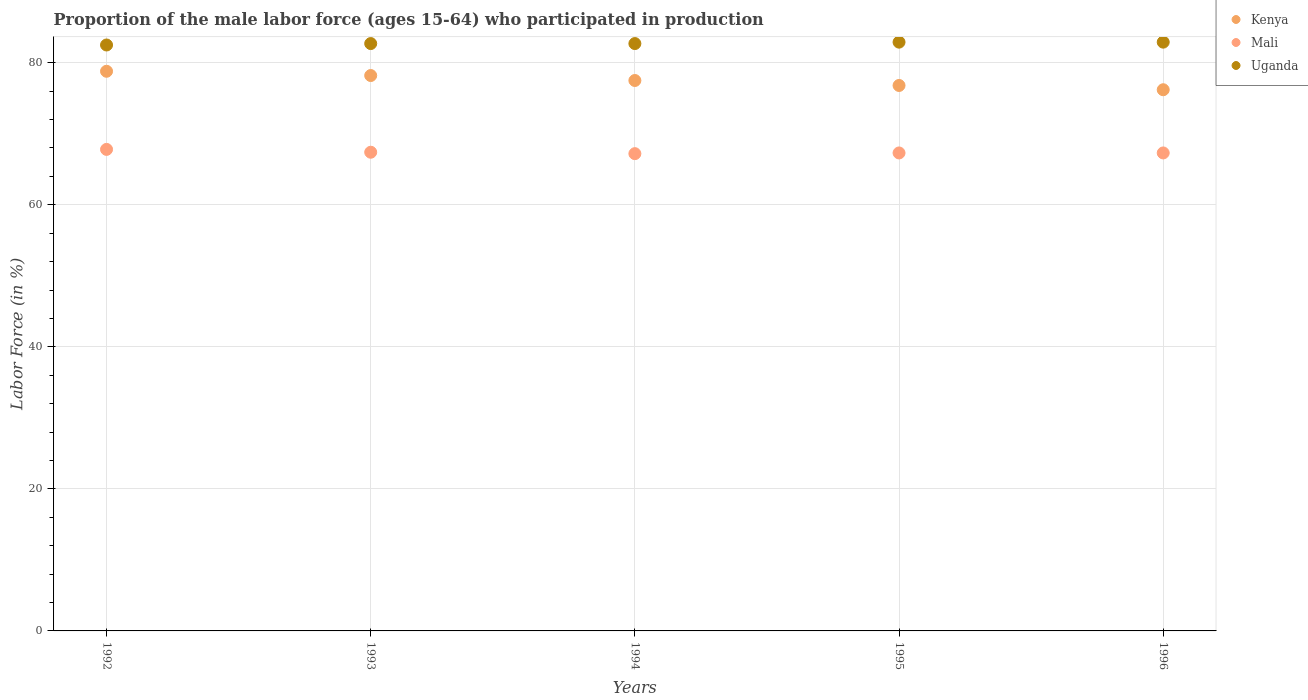How many different coloured dotlines are there?
Keep it short and to the point. 3. What is the proportion of the male labor force who participated in production in Uganda in 1993?
Your answer should be compact. 82.7. Across all years, what is the maximum proportion of the male labor force who participated in production in Uganda?
Make the answer very short. 82.9. Across all years, what is the minimum proportion of the male labor force who participated in production in Kenya?
Ensure brevity in your answer.  76.2. In which year was the proportion of the male labor force who participated in production in Kenya maximum?
Ensure brevity in your answer.  1992. In which year was the proportion of the male labor force who participated in production in Mali minimum?
Your answer should be very brief. 1994. What is the total proportion of the male labor force who participated in production in Mali in the graph?
Provide a succinct answer. 337. What is the difference between the proportion of the male labor force who participated in production in Uganda in 1992 and that in 1996?
Keep it short and to the point. -0.4. What is the average proportion of the male labor force who participated in production in Kenya per year?
Your answer should be very brief. 77.5. In the year 1994, what is the difference between the proportion of the male labor force who participated in production in Kenya and proportion of the male labor force who participated in production in Mali?
Your answer should be compact. 10.3. In how many years, is the proportion of the male labor force who participated in production in Mali greater than 76 %?
Keep it short and to the point. 0. What is the ratio of the proportion of the male labor force who participated in production in Kenya in 1992 to that in 1994?
Offer a very short reply. 1.02. Is the proportion of the male labor force who participated in production in Mali in 1992 less than that in 1996?
Offer a terse response. No. Is the difference between the proportion of the male labor force who participated in production in Kenya in 1992 and 1994 greater than the difference between the proportion of the male labor force who participated in production in Mali in 1992 and 1994?
Make the answer very short. Yes. What is the difference between the highest and the second highest proportion of the male labor force who participated in production in Kenya?
Keep it short and to the point. 0.6. What is the difference between the highest and the lowest proportion of the male labor force who participated in production in Kenya?
Give a very brief answer. 2.6. Is the sum of the proportion of the male labor force who participated in production in Mali in 1994 and 1995 greater than the maximum proportion of the male labor force who participated in production in Uganda across all years?
Your answer should be very brief. Yes. Does the proportion of the male labor force who participated in production in Mali monotonically increase over the years?
Provide a short and direct response. No. Are the values on the major ticks of Y-axis written in scientific E-notation?
Offer a very short reply. No. What is the title of the graph?
Make the answer very short. Proportion of the male labor force (ages 15-64) who participated in production. Does "Faeroe Islands" appear as one of the legend labels in the graph?
Provide a succinct answer. No. What is the label or title of the X-axis?
Keep it short and to the point. Years. What is the label or title of the Y-axis?
Offer a terse response. Labor Force (in %). What is the Labor Force (in %) of Kenya in 1992?
Give a very brief answer. 78.8. What is the Labor Force (in %) of Mali in 1992?
Keep it short and to the point. 67.8. What is the Labor Force (in %) in Uganda in 1992?
Offer a very short reply. 82.5. What is the Labor Force (in %) of Kenya in 1993?
Provide a short and direct response. 78.2. What is the Labor Force (in %) in Mali in 1993?
Ensure brevity in your answer.  67.4. What is the Labor Force (in %) of Uganda in 1993?
Offer a very short reply. 82.7. What is the Labor Force (in %) in Kenya in 1994?
Your answer should be very brief. 77.5. What is the Labor Force (in %) in Mali in 1994?
Make the answer very short. 67.2. What is the Labor Force (in %) in Uganda in 1994?
Your response must be concise. 82.7. What is the Labor Force (in %) in Kenya in 1995?
Your response must be concise. 76.8. What is the Labor Force (in %) of Mali in 1995?
Keep it short and to the point. 67.3. What is the Labor Force (in %) of Uganda in 1995?
Offer a terse response. 82.9. What is the Labor Force (in %) in Kenya in 1996?
Provide a succinct answer. 76.2. What is the Labor Force (in %) in Mali in 1996?
Provide a succinct answer. 67.3. What is the Labor Force (in %) of Uganda in 1996?
Provide a succinct answer. 82.9. Across all years, what is the maximum Labor Force (in %) in Kenya?
Your answer should be compact. 78.8. Across all years, what is the maximum Labor Force (in %) of Mali?
Your response must be concise. 67.8. Across all years, what is the maximum Labor Force (in %) of Uganda?
Your response must be concise. 82.9. Across all years, what is the minimum Labor Force (in %) in Kenya?
Give a very brief answer. 76.2. Across all years, what is the minimum Labor Force (in %) in Mali?
Offer a terse response. 67.2. Across all years, what is the minimum Labor Force (in %) of Uganda?
Provide a succinct answer. 82.5. What is the total Labor Force (in %) of Kenya in the graph?
Ensure brevity in your answer.  387.5. What is the total Labor Force (in %) of Mali in the graph?
Your answer should be compact. 337. What is the total Labor Force (in %) of Uganda in the graph?
Keep it short and to the point. 413.7. What is the difference between the Labor Force (in %) in Uganda in 1992 and that in 1993?
Give a very brief answer. -0.2. What is the difference between the Labor Force (in %) in Kenya in 1992 and that in 1994?
Give a very brief answer. 1.3. What is the difference between the Labor Force (in %) in Mali in 1992 and that in 1994?
Provide a succinct answer. 0.6. What is the difference between the Labor Force (in %) of Kenya in 1992 and that in 1995?
Your response must be concise. 2. What is the difference between the Labor Force (in %) in Uganda in 1992 and that in 1995?
Make the answer very short. -0.4. What is the difference between the Labor Force (in %) of Kenya in 1992 and that in 1996?
Keep it short and to the point. 2.6. What is the difference between the Labor Force (in %) in Uganda in 1992 and that in 1996?
Offer a terse response. -0.4. What is the difference between the Labor Force (in %) of Mali in 1993 and that in 1994?
Offer a very short reply. 0.2. What is the difference between the Labor Force (in %) in Uganda in 1993 and that in 1994?
Keep it short and to the point. 0. What is the difference between the Labor Force (in %) in Mali in 1993 and that in 1995?
Offer a very short reply. 0.1. What is the difference between the Labor Force (in %) of Mali in 1993 and that in 1996?
Give a very brief answer. 0.1. What is the difference between the Labor Force (in %) of Uganda in 1993 and that in 1996?
Provide a succinct answer. -0.2. What is the difference between the Labor Force (in %) of Kenya in 1994 and that in 1995?
Ensure brevity in your answer.  0.7. What is the difference between the Labor Force (in %) of Mali in 1994 and that in 1995?
Give a very brief answer. -0.1. What is the difference between the Labor Force (in %) of Kenya in 1994 and that in 1996?
Give a very brief answer. 1.3. What is the difference between the Labor Force (in %) in Mali in 1994 and that in 1996?
Give a very brief answer. -0.1. What is the difference between the Labor Force (in %) of Uganda in 1994 and that in 1996?
Provide a short and direct response. -0.2. What is the difference between the Labor Force (in %) in Kenya in 1995 and that in 1996?
Keep it short and to the point. 0.6. What is the difference between the Labor Force (in %) of Mali in 1995 and that in 1996?
Keep it short and to the point. 0. What is the difference between the Labor Force (in %) of Kenya in 1992 and the Labor Force (in %) of Mali in 1993?
Ensure brevity in your answer.  11.4. What is the difference between the Labor Force (in %) of Kenya in 1992 and the Labor Force (in %) of Uganda in 1993?
Your answer should be very brief. -3.9. What is the difference between the Labor Force (in %) in Mali in 1992 and the Labor Force (in %) in Uganda in 1993?
Provide a succinct answer. -14.9. What is the difference between the Labor Force (in %) of Kenya in 1992 and the Labor Force (in %) of Uganda in 1994?
Provide a short and direct response. -3.9. What is the difference between the Labor Force (in %) in Mali in 1992 and the Labor Force (in %) in Uganda in 1994?
Keep it short and to the point. -14.9. What is the difference between the Labor Force (in %) in Kenya in 1992 and the Labor Force (in %) in Mali in 1995?
Offer a very short reply. 11.5. What is the difference between the Labor Force (in %) of Kenya in 1992 and the Labor Force (in %) of Uganda in 1995?
Offer a very short reply. -4.1. What is the difference between the Labor Force (in %) in Mali in 1992 and the Labor Force (in %) in Uganda in 1995?
Keep it short and to the point. -15.1. What is the difference between the Labor Force (in %) of Mali in 1992 and the Labor Force (in %) of Uganda in 1996?
Offer a terse response. -15.1. What is the difference between the Labor Force (in %) of Kenya in 1993 and the Labor Force (in %) of Mali in 1994?
Ensure brevity in your answer.  11. What is the difference between the Labor Force (in %) in Mali in 1993 and the Labor Force (in %) in Uganda in 1994?
Your response must be concise. -15.3. What is the difference between the Labor Force (in %) in Kenya in 1993 and the Labor Force (in %) in Mali in 1995?
Give a very brief answer. 10.9. What is the difference between the Labor Force (in %) in Kenya in 1993 and the Labor Force (in %) in Uganda in 1995?
Offer a very short reply. -4.7. What is the difference between the Labor Force (in %) in Mali in 1993 and the Labor Force (in %) in Uganda in 1995?
Provide a succinct answer. -15.5. What is the difference between the Labor Force (in %) of Kenya in 1993 and the Labor Force (in %) of Uganda in 1996?
Provide a succinct answer. -4.7. What is the difference between the Labor Force (in %) in Mali in 1993 and the Labor Force (in %) in Uganda in 1996?
Provide a short and direct response. -15.5. What is the difference between the Labor Force (in %) of Kenya in 1994 and the Labor Force (in %) of Uganda in 1995?
Your response must be concise. -5.4. What is the difference between the Labor Force (in %) of Mali in 1994 and the Labor Force (in %) of Uganda in 1995?
Offer a terse response. -15.7. What is the difference between the Labor Force (in %) in Mali in 1994 and the Labor Force (in %) in Uganda in 1996?
Your response must be concise. -15.7. What is the difference between the Labor Force (in %) in Kenya in 1995 and the Labor Force (in %) in Mali in 1996?
Offer a very short reply. 9.5. What is the difference between the Labor Force (in %) of Mali in 1995 and the Labor Force (in %) of Uganda in 1996?
Give a very brief answer. -15.6. What is the average Labor Force (in %) in Kenya per year?
Offer a very short reply. 77.5. What is the average Labor Force (in %) in Mali per year?
Offer a terse response. 67.4. What is the average Labor Force (in %) in Uganda per year?
Offer a terse response. 82.74. In the year 1992, what is the difference between the Labor Force (in %) of Kenya and Labor Force (in %) of Mali?
Offer a terse response. 11. In the year 1992, what is the difference between the Labor Force (in %) of Mali and Labor Force (in %) of Uganda?
Offer a terse response. -14.7. In the year 1993, what is the difference between the Labor Force (in %) of Kenya and Labor Force (in %) of Mali?
Give a very brief answer. 10.8. In the year 1993, what is the difference between the Labor Force (in %) in Kenya and Labor Force (in %) in Uganda?
Make the answer very short. -4.5. In the year 1993, what is the difference between the Labor Force (in %) of Mali and Labor Force (in %) of Uganda?
Provide a succinct answer. -15.3. In the year 1994, what is the difference between the Labor Force (in %) in Kenya and Labor Force (in %) in Mali?
Offer a very short reply. 10.3. In the year 1994, what is the difference between the Labor Force (in %) of Kenya and Labor Force (in %) of Uganda?
Your answer should be very brief. -5.2. In the year 1994, what is the difference between the Labor Force (in %) of Mali and Labor Force (in %) of Uganda?
Ensure brevity in your answer.  -15.5. In the year 1995, what is the difference between the Labor Force (in %) in Kenya and Labor Force (in %) in Mali?
Give a very brief answer. 9.5. In the year 1995, what is the difference between the Labor Force (in %) in Kenya and Labor Force (in %) in Uganda?
Ensure brevity in your answer.  -6.1. In the year 1995, what is the difference between the Labor Force (in %) in Mali and Labor Force (in %) in Uganda?
Provide a short and direct response. -15.6. In the year 1996, what is the difference between the Labor Force (in %) of Mali and Labor Force (in %) of Uganda?
Provide a short and direct response. -15.6. What is the ratio of the Labor Force (in %) of Kenya in 1992 to that in 1993?
Your answer should be compact. 1.01. What is the ratio of the Labor Force (in %) in Mali in 1992 to that in 1993?
Offer a terse response. 1.01. What is the ratio of the Labor Force (in %) of Kenya in 1992 to that in 1994?
Keep it short and to the point. 1.02. What is the ratio of the Labor Force (in %) in Mali in 1992 to that in 1994?
Give a very brief answer. 1.01. What is the ratio of the Labor Force (in %) of Mali in 1992 to that in 1995?
Offer a very short reply. 1.01. What is the ratio of the Labor Force (in %) in Kenya in 1992 to that in 1996?
Ensure brevity in your answer.  1.03. What is the ratio of the Labor Force (in %) in Mali in 1992 to that in 1996?
Your answer should be very brief. 1.01. What is the ratio of the Labor Force (in %) of Mali in 1993 to that in 1994?
Offer a very short reply. 1. What is the ratio of the Labor Force (in %) of Uganda in 1993 to that in 1994?
Ensure brevity in your answer.  1. What is the ratio of the Labor Force (in %) in Kenya in 1993 to that in 1995?
Offer a terse response. 1.02. What is the ratio of the Labor Force (in %) of Uganda in 1993 to that in 1995?
Ensure brevity in your answer.  1. What is the ratio of the Labor Force (in %) of Kenya in 1993 to that in 1996?
Your answer should be compact. 1.03. What is the ratio of the Labor Force (in %) in Mali in 1993 to that in 1996?
Provide a succinct answer. 1. What is the ratio of the Labor Force (in %) of Kenya in 1994 to that in 1995?
Offer a terse response. 1.01. What is the ratio of the Labor Force (in %) in Mali in 1994 to that in 1995?
Offer a very short reply. 1. What is the ratio of the Labor Force (in %) of Kenya in 1994 to that in 1996?
Provide a short and direct response. 1.02. What is the ratio of the Labor Force (in %) in Uganda in 1994 to that in 1996?
Offer a very short reply. 1. What is the ratio of the Labor Force (in %) of Kenya in 1995 to that in 1996?
Provide a succinct answer. 1.01. What is the difference between the highest and the second highest Labor Force (in %) of Uganda?
Ensure brevity in your answer.  0. What is the difference between the highest and the lowest Labor Force (in %) in Uganda?
Provide a succinct answer. 0.4. 